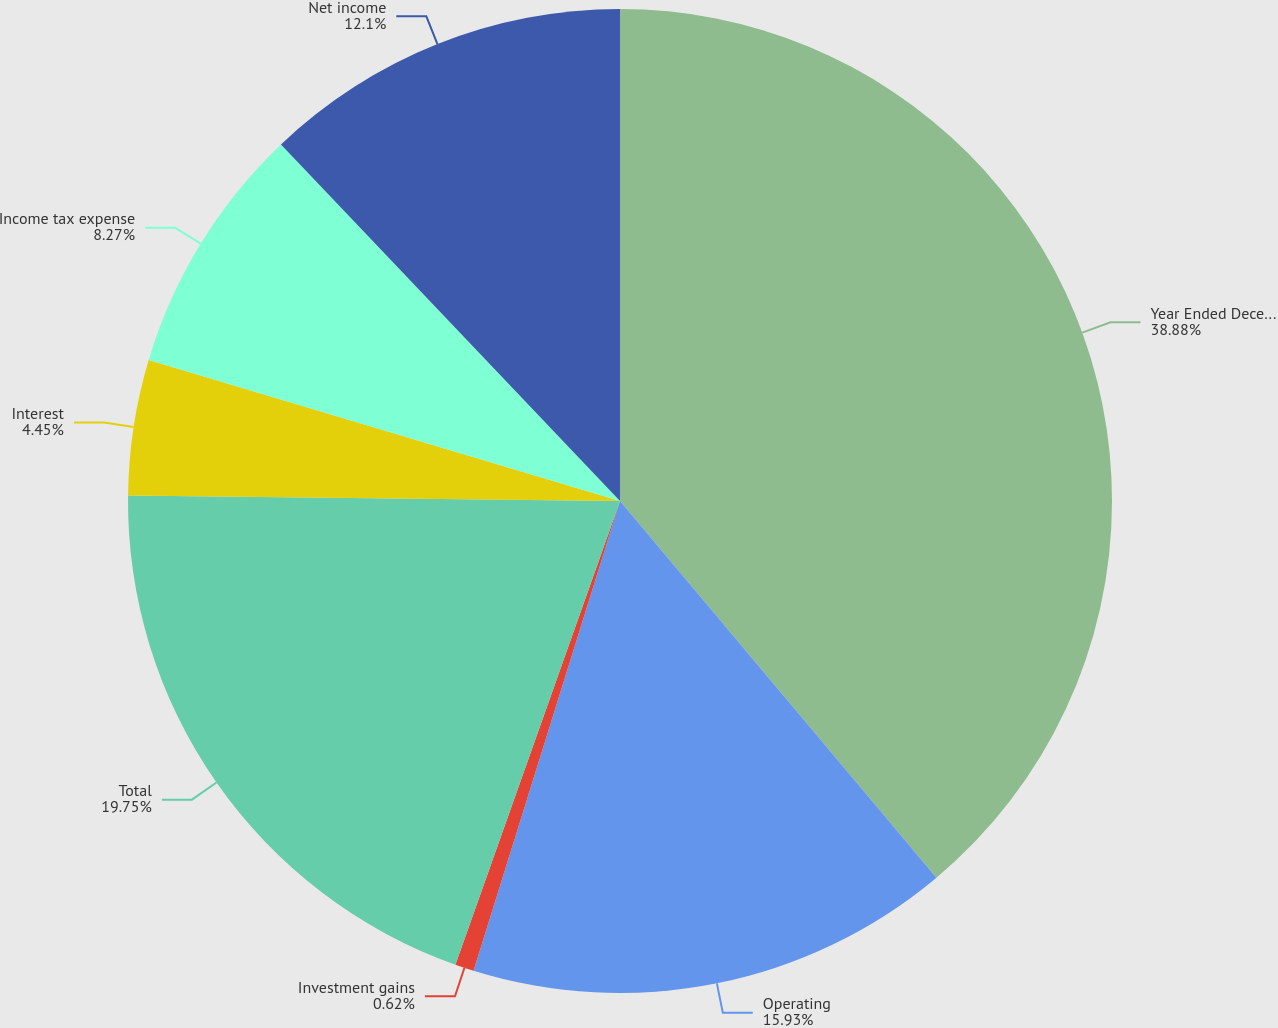Convert chart. <chart><loc_0><loc_0><loc_500><loc_500><pie_chart><fcel>Year Ended December 31<fcel>Operating<fcel>Investment gains<fcel>Total<fcel>Interest<fcel>Income tax expense<fcel>Net income<nl><fcel>38.88%<fcel>15.93%<fcel>0.62%<fcel>19.75%<fcel>4.45%<fcel>8.27%<fcel>12.1%<nl></chart> 